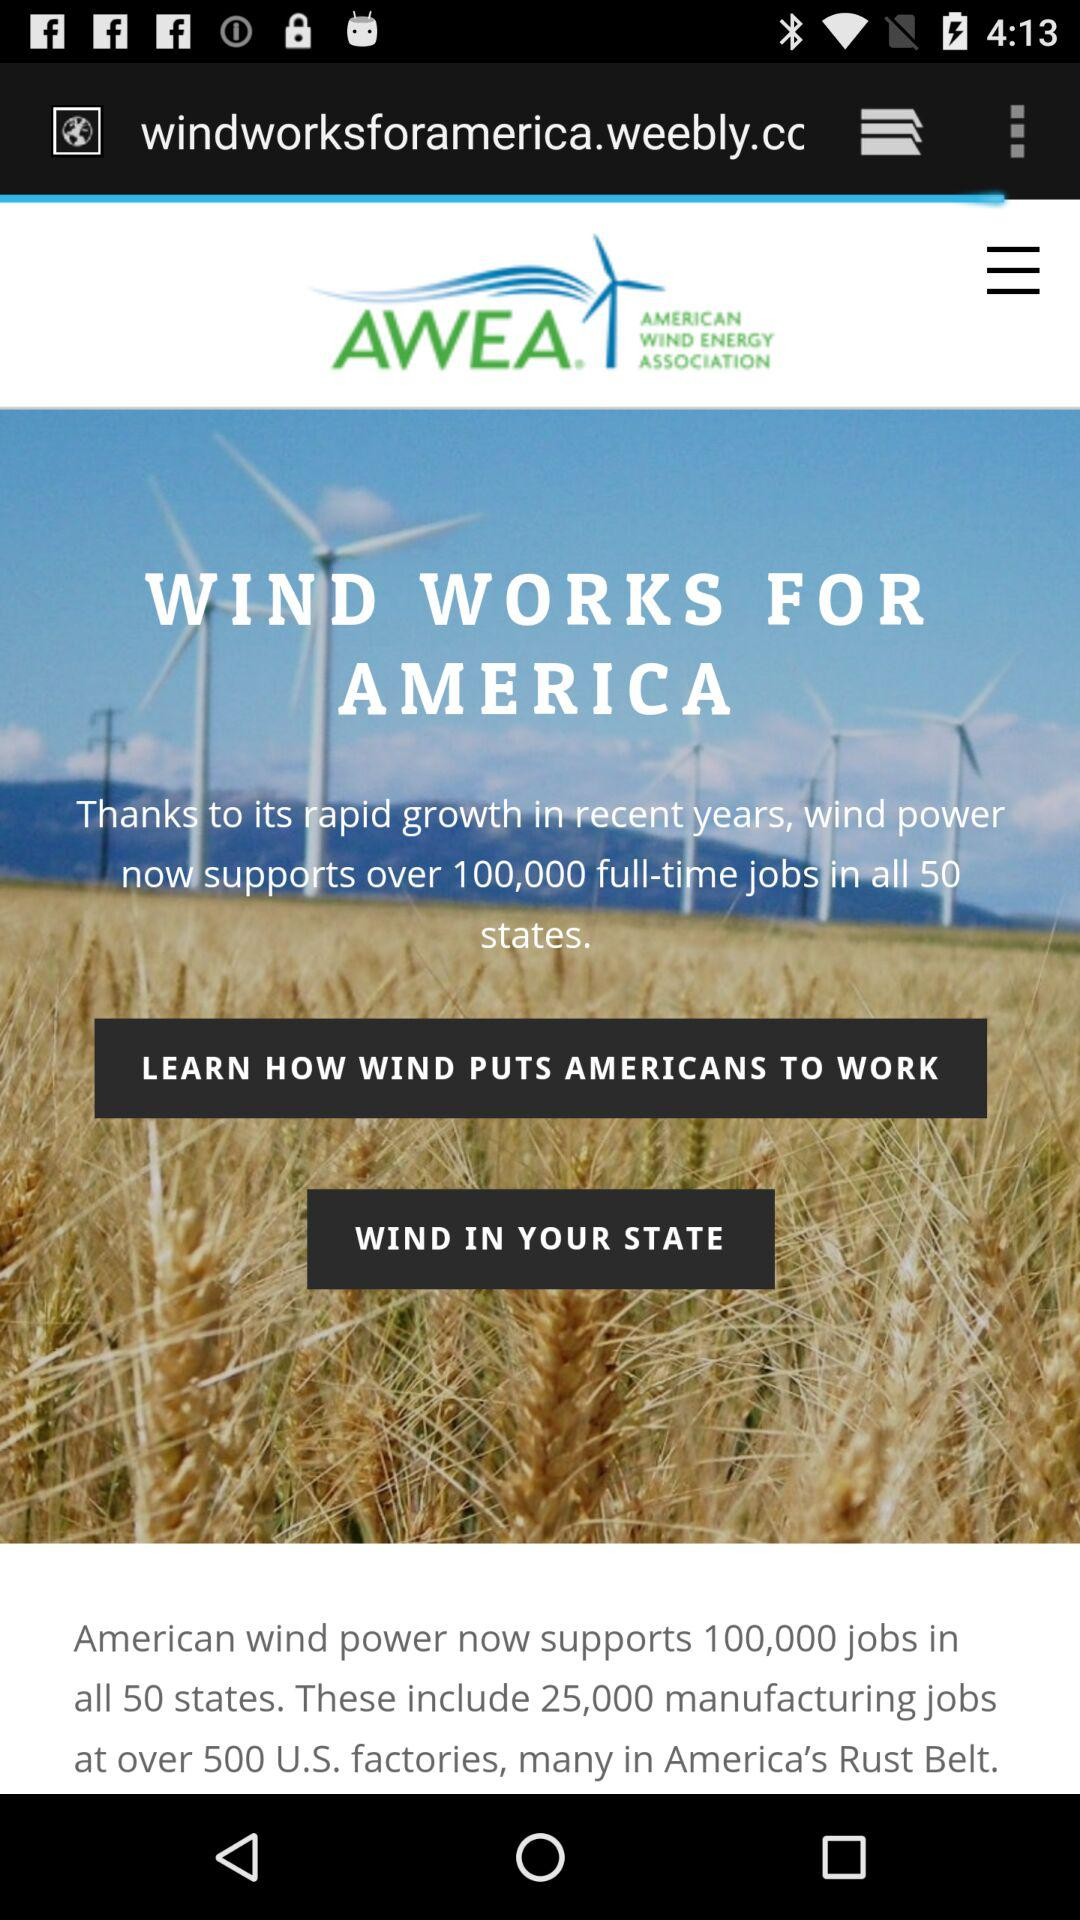How many jobs does American wind power support now? American wind power now supports 100,000 jobs. 